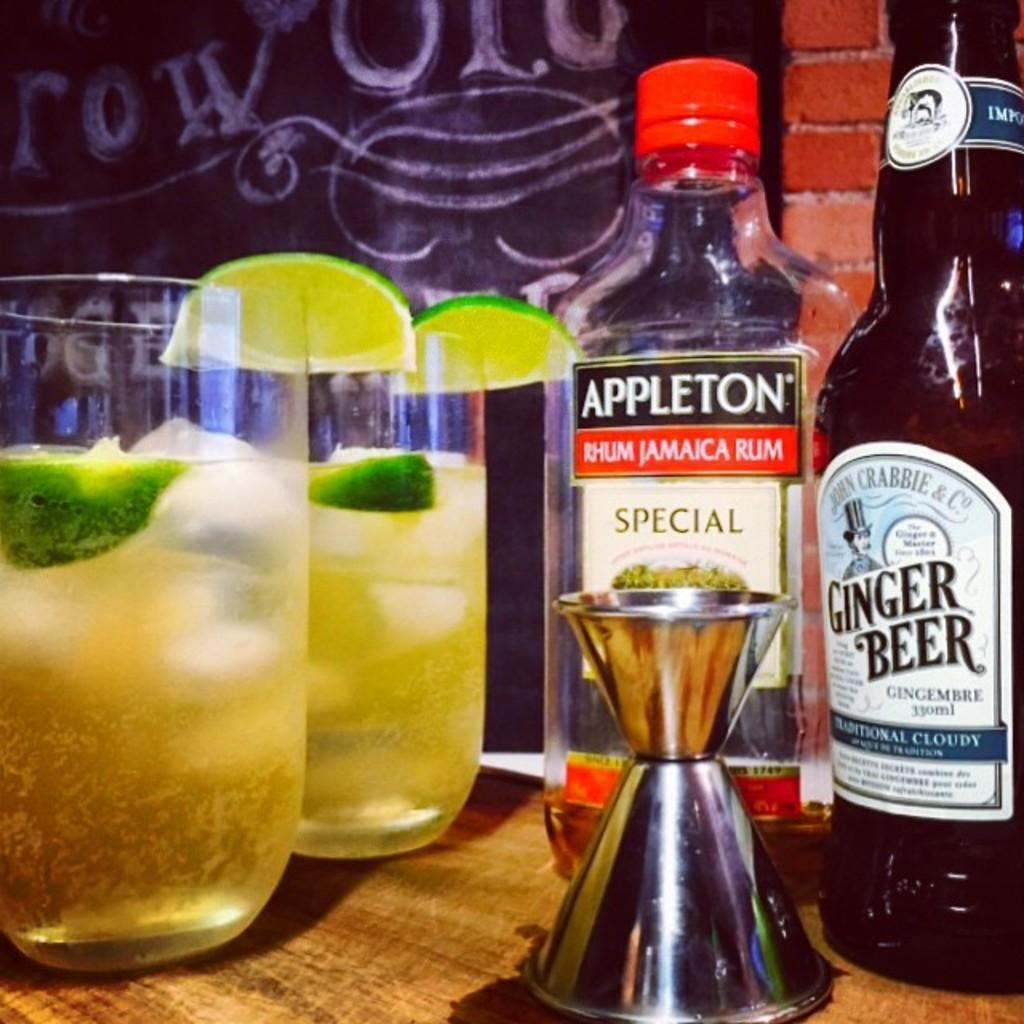What objects are on the table in the image? There are glasses and bottles on the table in the image. What is inside the glasses? There are lemons in the glasses. What type of growth can be seen on the church in the image? There is no church present in the image, so it is not possible to determine what type of growth might be observed. 